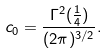<formula> <loc_0><loc_0><loc_500><loc_500>c _ { 0 } = \frac { \Gamma ^ { 2 } ( \frac { 1 } { 4 } ) } { ( 2 \pi ) ^ { 3 / 2 } } .</formula> 